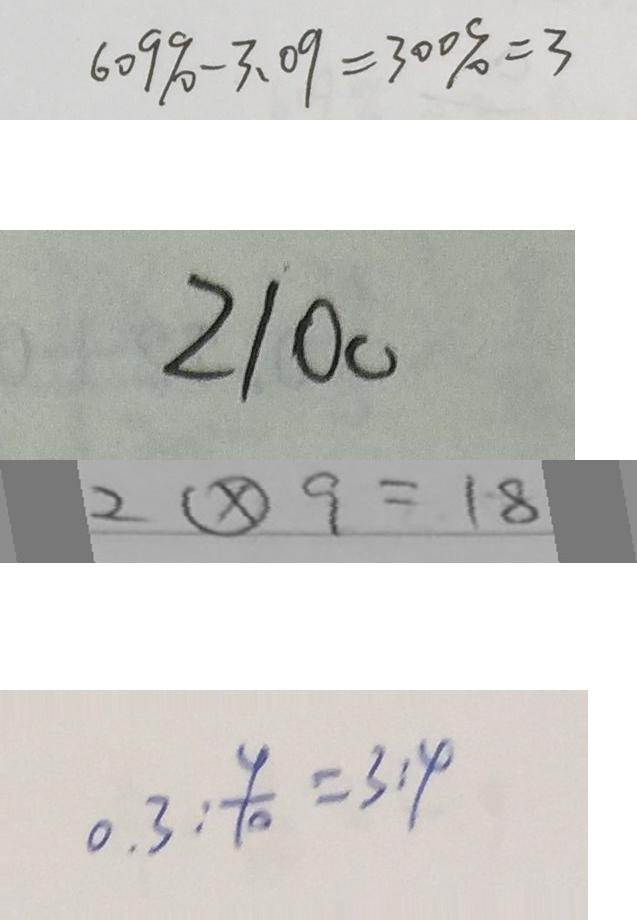Convert formula to latex. <formula><loc_0><loc_0><loc_500><loc_500>6 0 9 \% - 3 . 0 9 = 3 0 0 \% = 3 
 2 1 0 0 
 2 \textcircled { \times } 9 = 1 8 
 0 . 3 : \frac { 4 } { 1 0 } = 3 : 4</formula> 